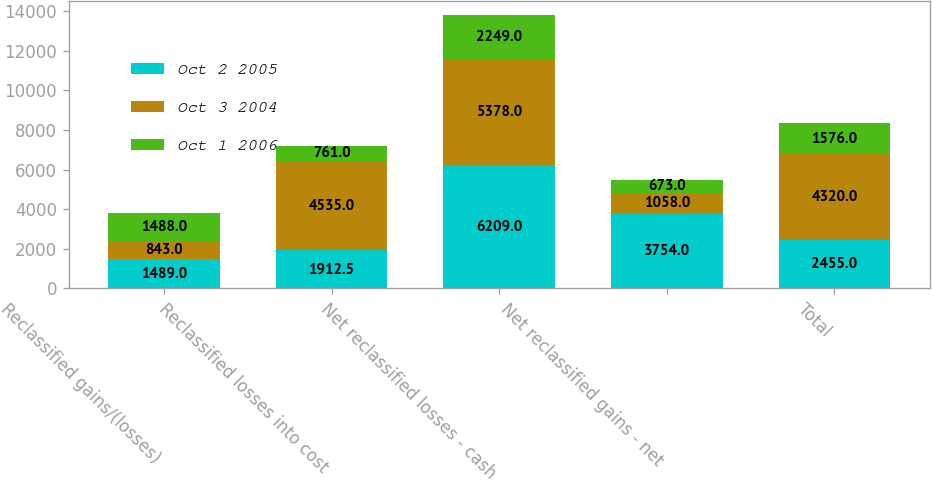Convert chart. <chart><loc_0><loc_0><loc_500><loc_500><stacked_bar_chart><ecel><fcel>Reclassified gains/(losses)<fcel>Reclassified losses into cost<fcel>Net reclassified losses - cash<fcel>Net reclassified gains - net<fcel>Total<nl><fcel>Oct 2 2005<fcel>1489<fcel>1912.5<fcel>6209<fcel>3754<fcel>2455<nl><fcel>Oct 3 2004<fcel>843<fcel>4535<fcel>5378<fcel>1058<fcel>4320<nl><fcel>Oct 1 2006<fcel>1488<fcel>761<fcel>2249<fcel>673<fcel>1576<nl></chart> 